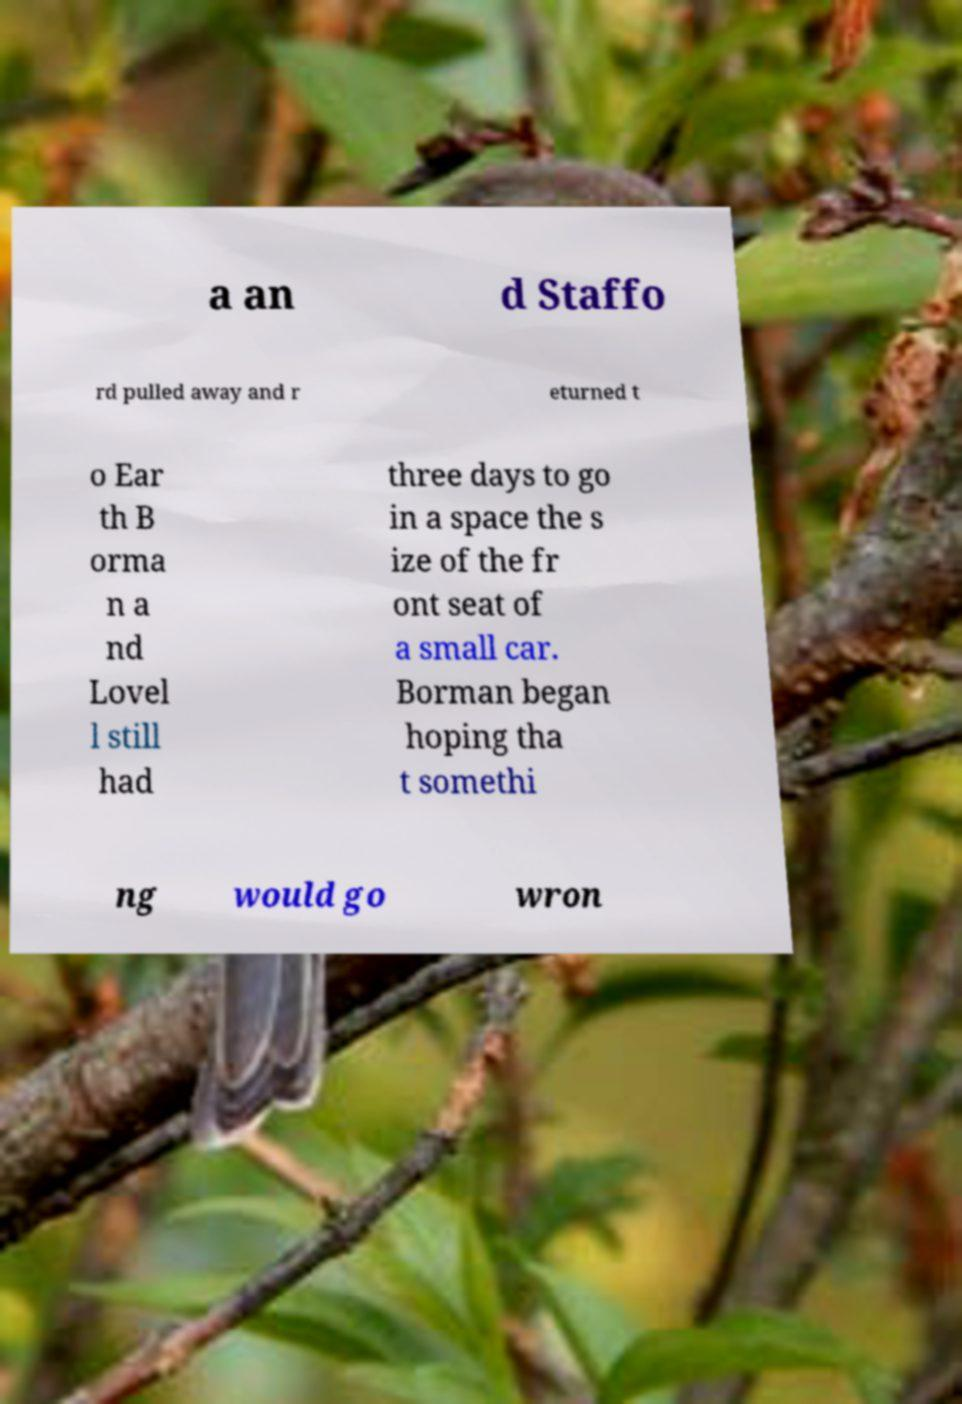I need the written content from this picture converted into text. Can you do that? a an d Staffo rd pulled away and r eturned t o Ear th B orma n a nd Lovel l still had three days to go in a space the s ize of the fr ont seat of a small car. Borman began hoping tha t somethi ng would go wron 